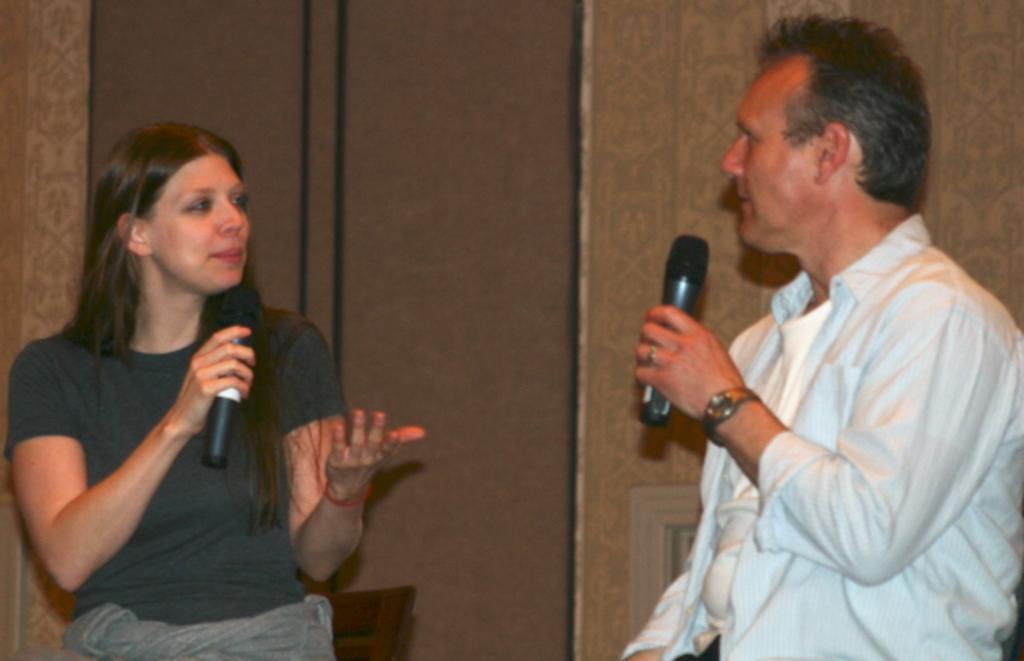In one or two sentences, can you explain what this image depicts? In this picture there is a lady holding a mic in her right hand. There is a man opposite to that lady he is standing and holding a mic in his left hand. There is watch to his hand and ring to his finger. And in the background there is a wall. 